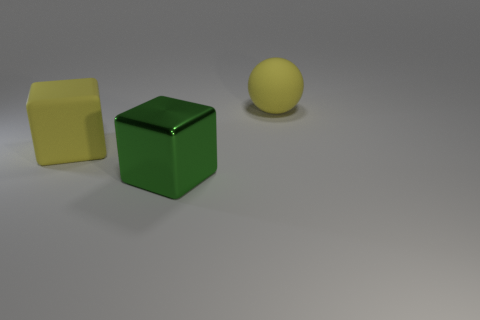Add 1 large yellow rubber objects. How many objects exist? 4 Subtract all spheres. How many objects are left? 2 Add 3 large yellow blocks. How many large yellow blocks are left? 4 Add 3 green metallic objects. How many green metallic objects exist? 4 Subtract 0 gray cubes. How many objects are left? 3 Subtract all red matte spheres. Subtract all yellow spheres. How many objects are left? 2 